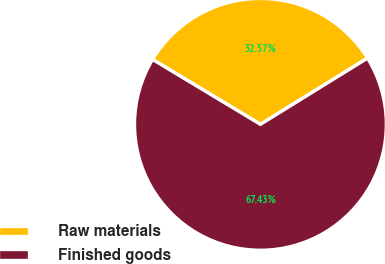Convert chart to OTSL. <chart><loc_0><loc_0><loc_500><loc_500><pie_chart><fcel>Raw materials<fcel>Finished goods<nl><fcel>32.57%<fcel>67.43%<nl></chart> 